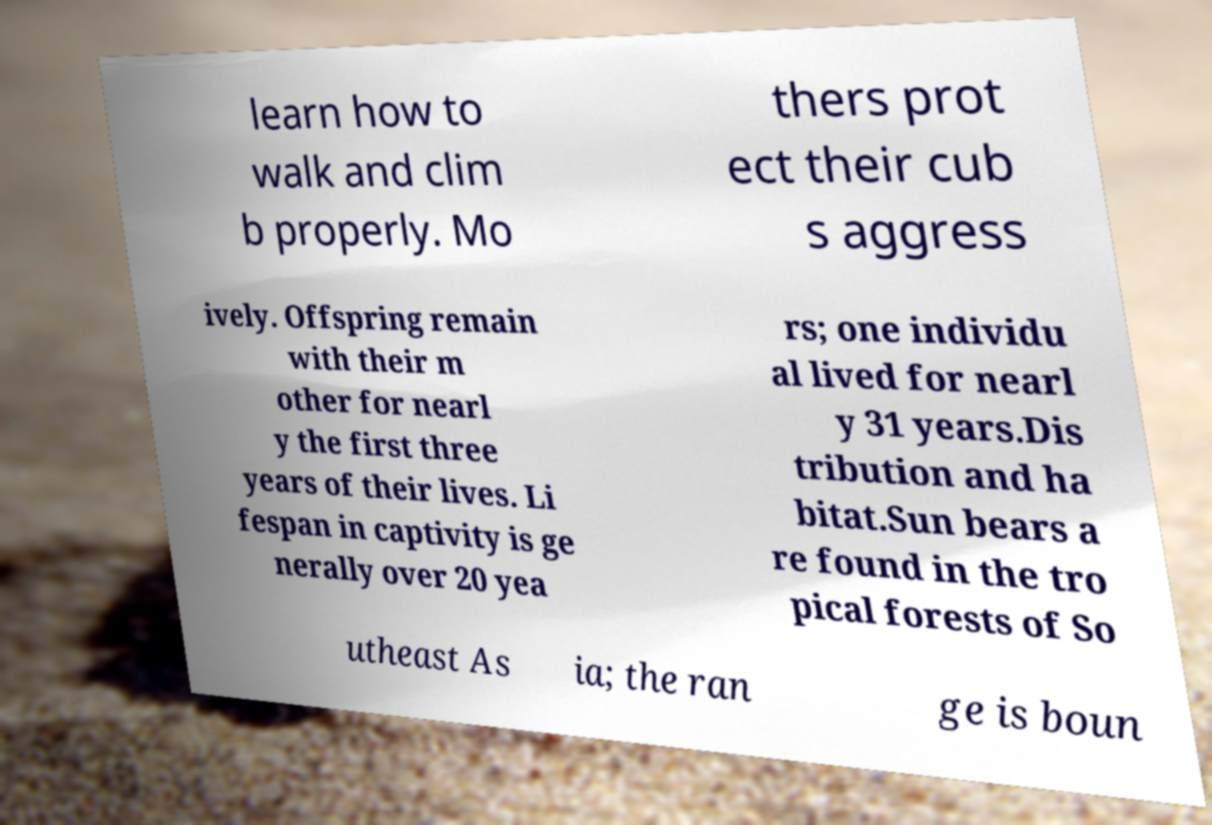What messages or text are displayed in this image? I need them in a readable, typed format. learn how to walk and clim b properly. Mo thers prot ect their cub s aggress ively. Offspring remain with their m other for nearl y the first three years of their lives. Li fespan in captivity is ge nerally over 20 yea rs; one individu al lived for nearl y 31 years.Dis tribution and ha bitat.Sun bears a re found in the tro pical forests of So utheast As ia; the ran ge is boun 